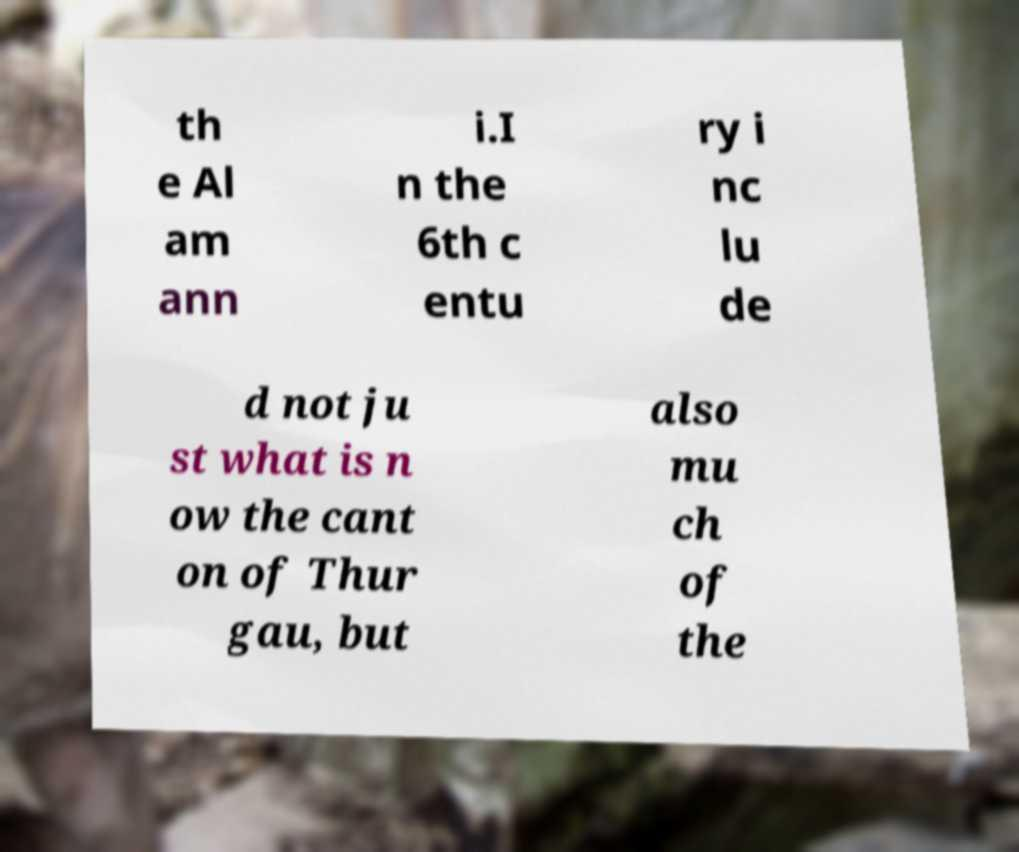Can you read and provide the text displayed in the image?This photo seems to have some interesting text. Can you extract and type it out for me? th e Al am ann i.I n the 6th c entu ry i nc lu de d not ju st what is n ow the cant on of Thur gau, but also mu ch of the 